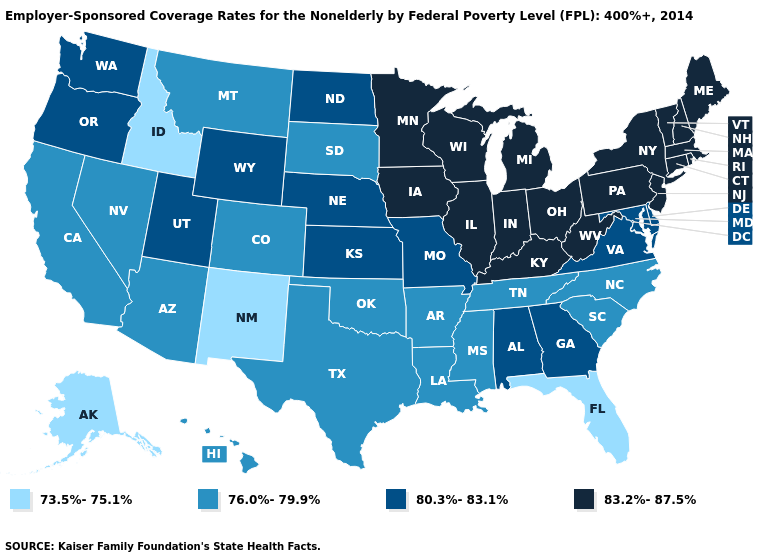Name the states that have a value in the range 76.0%-79.9%?
Answer briefly. Arizona, Arkansas, California, Colorado, Hawaii, Louisiana, Mississippi, Montana, Nevada, North Carolina, Oklahoma, South Carolina, South Dakota, Tennessee, Texas. Name the states that have a value in the range 73.5%-75.1%?
Quick response, please. Alaska, Florida, Idaho, New Mexico. What is the value of Nebraska?
Concise answer only. 80.3%-83.1%. Does Rhode Island have the highest value in the USA?
Give a very brief answer. Yes. Does Florida have the lowest value in the South?
Quick response, please. Yes. What is the value of Oregon?
Short answer required. 80.3%-83.1%. Does Missouri have a higher value than Mississippi?
Keep it brief. Yes. Among the states that border Iowa , does Wisconsin have the highest value?
Quick response, please. Yes. Among the states that border New Jersey , which have the highest value?
Write a very short answer. New York, Pennsylvania. What is the value of Connecticut?
Concise answer only. 83.2%-87.5%. What is the value of Massachusetts?
Short answer required. 83.2%-87.5%. What is the value of New Mexico?
Be succinct. 73.5%-75.1%. Does Vermont have the same value as New Jersey?
Write a very short answer. Yes. What is the value of Michigan?
Keep it brief. 83.2%-87.5%. Among the states that border South Carolina , does Georgia have the lowest value?
Concise answer only. No. 